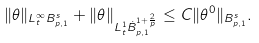Convert formula to latex. <formula><loc_0><loc_0><loc_500><loc_500>\| \theta \| _ { L ^ { \infty } _ { t } B _ { p , 1 } ^ { s } } + \| \theta \| _ { L ^ { 1 } _ { t } \dot { B } _ { p , 1 } ^ { 1 + \frac { 2 } { p } } } \leq C \| \theta ^ { 0 } \| _ { B _ { p , 1 } ^ { s } } .</formula> 